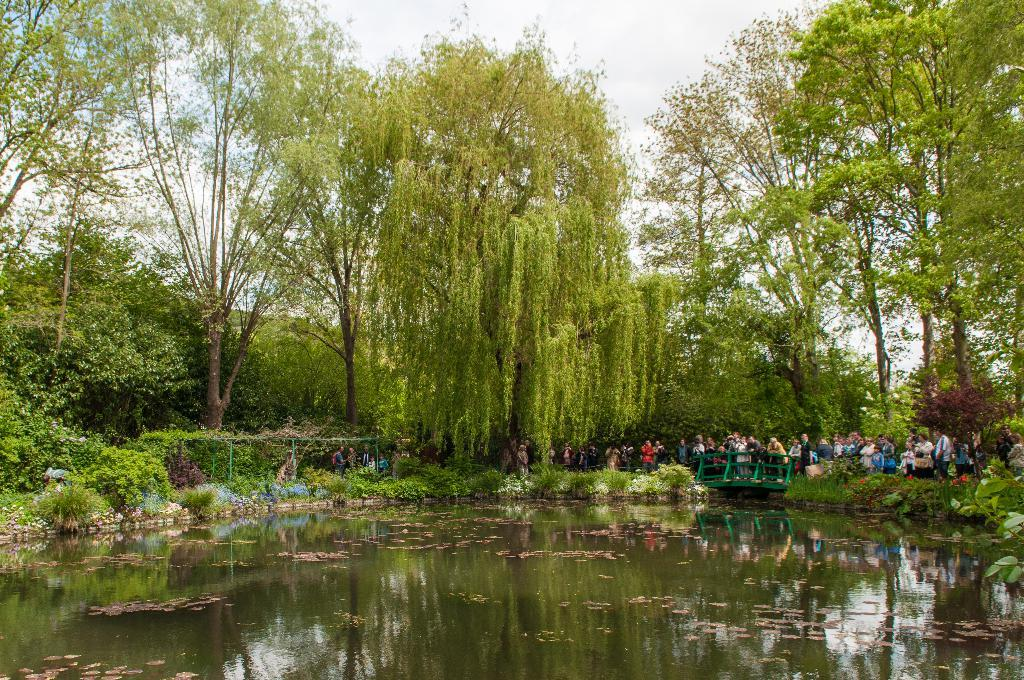What is located in the front of the image? There is a small water pond in the front of the image. What are the people in the image doing? People are standing behind the water pond and looking into it. What can be seen in the background of the image? There are huge trees in the background of the image. Reasoning: Let's think step by step to produce the conversation. We start by identifying the main subject in the image, which is the small water pond. Then, we describe the actions of the people in the image, noting that they are standing behind the pond and looking into it. Finally, we mention the background of the image, which features huge trees. Each question is based on the provided facts and can be answered definitively. Absurd Question/Answer: What type of underwear is the person in the image wearing? There is no information about the person's underwear in the image, so it cannot be determined. 